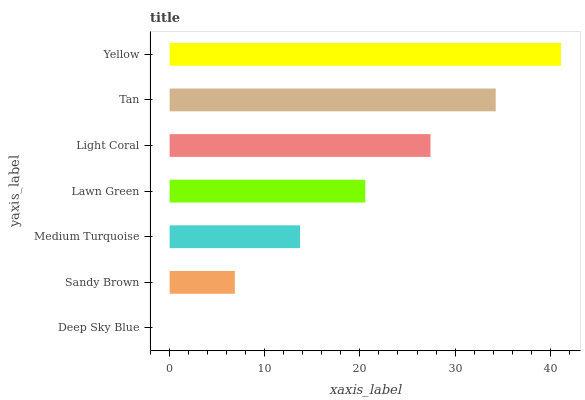Is Deep Sky Blue the minimum?
Answer yes or no. Yes. Is Yellow the maximum?
Answer yes or no. Yes. Is Sandy Brown the minimum?
Answer yes or no. No. Is Sandy Brown the maximum?
Answer yes or no. No. Is Sandy Brown greater than Deep Sky Blue?
Answer yes or no. Yes. Is Deep Sky Blue less than Sandy Brown?
Answer yes or no. Yes. Is Deep Sky Blue greater than Sandy Brown?
Answer yes or no. No. Is Sandy Brown less than Deep Sky Blue?
Answer yes or no. No. Is Lawn Green the high median?
Answer yes or no. Yes. Is Lawn Green the low median?
Answer yes or no. Yes. Is Yellow the high median?
Answer yes or no. No. Is Tan the low median?
Answer yes or no. No. 